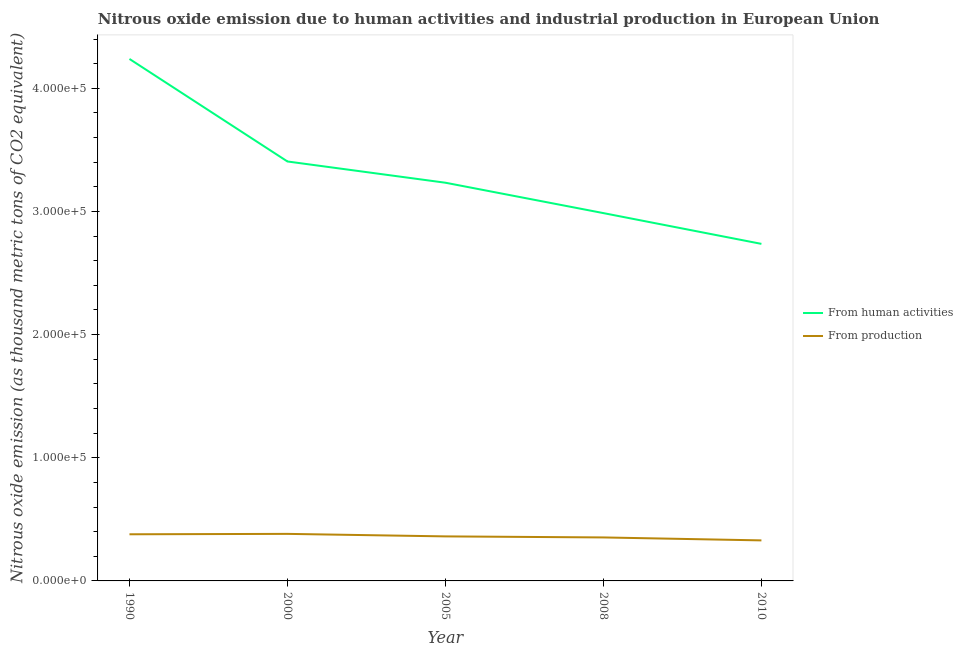Does the line corresponding to amount of emissions generated from industries intersect with the line corresponding to amount of emissions from human activities?
Offer a terse response. No. What is the amount of emissions generated from industries in 2000?
Offer a terse response. 3.82e+04. Across all years, what is the maximum amount of emissions generated from industries?
Your answer should be very brief. 3.82e+04. Across all years, what is the minimum amount of emissions generated from industries?
Offer a very short reply. 3.29e+04. In which year was the amount of emissions from human activities maximum?
Give a very brief answer. 1990. What is the total amount of emissions generated from industries in the graph?
Your response must be concise. 1.80e+05. What is the difference between the amount of emissions generated from industries in 1990 and that in 2000?
Your response must be concise. -328.9. What is the difference between the amount of emissions from human activities in 2008 and the amount of emissions generated from industries in 2000?
Make the answer very short. 2.60e+05. What is the average amount of emissions from human activities per year?
Give a very brief answer. 3.32e+05. In the year 2008, what is the difference between the amount of emissions generated from industries and amount of emissions from human activities?
Keep it short and to the point. -2.63e+05. What is the ratio of the amount of emissions from human activities in 2005 to that in 2008?
Offer a terse response. 1.08. Is the amount of emissions from human activities in 1990 less than that in 2000?
Your response must be concise. No. What is the difference between the highest and the second highest amount of emissions generated from industries?
Keep it short and to the point. 328.9. What is the difference between the highest and the lowest amount of emissions generated from industries?
Your answer should be very brief. 5298.1. Is the sum of the amount of emissions from human activities in 1990 and 2010 greater than the maximum amount of emissions generated from industries across all years?
Your response must be concise. Yes. Does the amount of emissions generated from industries monotonically increase over the years?
Your answer should be very brief. No. Is the amount of emissions generated from industries strictly less than the amount of emissions from human activities over the years?
Offer a very short reply. Yes. How many lines are there?
Keep it short and to the point. 2. Are the values on the major ticks of Y-axis written in scientific E-notation?
Make the answer very short. Yes. Does the graph contain any zero values?
Ensure brevity in your answer.  No. Does the graph contain grids?
Offer a very short reply. No. How many legend labels are there?
Your answer should be compact. 2. What is the title of the graph?
Provide a short and direct response. Nitrous oxide emission due to human activities and industrial production in European Union. What is the label or title of the X-axis?
Ensure brevity in your answer.  Year. What is the label or title of the Y-axis?
Ensure brevity in your answer.  Nitrous oxide emission (as thousand metric tons of CO2 equivalent). What is the Nitrous oxide emission (as thousand metric tons of CO2 equivalent) in From human activities in 1990?
Your response must be concise. 4.24e+05. What is the Nitrous oxide emission (as thousand metric tons of CO2 equivalent) in From production in 1990?
Offer a terse response. 3.79e+04. What is the Nitrous oxide emission (as thousand metric tons of CO2 equivalent) of From human activities in 2000?
Keep it short and to the point. 3.41e+05. What is the Nitrous oxide emission (as thousand metric tons of CO2 equivalent) of From production in 2000?
Keep it short and to the point. 3.82e+04. What is the Nitrous oxide emission (as thousand metric tons of CO2 equivalent) of From human activities in 2005?
Your response must be concise. 3.23e+05. What is the Nitrous oxide emission (as thousand metric tons of CO2 equivalent) in From production in 2005?
Your answer should be very brief. 3.62e+04. What is the Nitrous oxide emission (as thousand metric tons of CO2 equivalent) of From human activities in 2008?
Give a very brief answer. 2.99e+05. What is the Nitrous oxide emission (as thousand metric tons of CO2 equivalent) of From production in 2008?
Provide a short and direct response. 3.53e+04. What is the Nitrous oxide emission (as thousand metric tons of CO2 equivalent) of From human activities in 2010?
Ensure brevity in your answer.  2.74e+05. What is the Nitrous oxide emission (as thousand metric tons of CO2 equivalent) of From production in 2010?
Provide a succinct answer. 3.29e+04. Across all years, what is the maximum Nitrous oxide emission (as thousand metric tons of CO2 equivalent) of From human activities?
Your answer should be very brief. 4.24e+05. Across all years, what is the maximum Nitrous oxide emission (as thousand metric tons of CO2 equivalent) of From production?
Give a very brief answer. 3.82e+04. Across all years, what is the minimum Nitrous oxide emission (as thousand metric tons of CO2 equivalent) in From human activities?
Your answer should be compact. 2.74e+05. Across all years, what is the minimum Nitrous oxide emission (as thousand metric tons of CO2 equivalent) in From production?
Your answer should be compact. 3.29e+04. What is the total Nitrous oxide emission (as thousand metric tons of CO2 equivalent) in From human activities in the graph?
Your answer should be compact. 1.66e+06. What is the total Nitrous oxide emission (as thousand metric tons of CO2 equivalent) in From production in the graph?
Ensure brevity in your answer.  1.80e+05. What is the difference between the Nitrous oxide emission (as thousand metric tons of CO2 equivalent) in From human activities in 1990 and that in 2000?
Offer a very short reply. 8.33e+04. What is the difference between the Nitrous oxide emission (as thousand metric tons of CO2 equivalent) of From production in 1990 and that in 2000?
Give a very brief answer. -328.9. What is the difference between the Nitrous oxide emission (as thousand metric tons of CO2 equivalent) of From human activities in 1990 and that in 2005?
Keep it short and to the point. 1.01e+05. What is the difference between the Nitrous oxide emission (as thousand metric tons of CO2 equivalent) in From production in 1990 and that in 2005?
Offer a very short reply. 1721.7. What is the difference between the Nitrous oxide emission (as thousand metric tons of CO2 equivalent) in From human activities in 1990 and that in 2008?
Provide a succinct answer. 1.25e+05. What is the difference between the Nitrous oxide emission (as thousand metric tons of CO2 equivalent) of From production in 1990 and that in 2008?
Offer a very short reply. 2566.7. What is the difference between the Nitrous oxide emission (as thousand metric tons of CO2 equivalent) of From human activities in 1990 and that in 2010?
Provide a short and direct response. 1.50e+05. What is the difference between the Nitrous oxide emission (as thousand metric tons of CO2 equivalent) of From production in 1990 and that in 2010?
Provide a short and direct response. 4969.2. What is the difference between the Nitrous oxide emission (as thousand metric tons of CO2 equivalent) in From human activities in 2000 and that in 2005?
Provide a succinct answer. 1.72e+04. What is the difference between the Nitrous oxide emission (as thousand metric tons of CO2 equivalent) in From production in 2000 and that in 2005?
Offer a terse response. 2050.6. What is the difference between the Nitrous oxide emission (as thousand metric tons of CO2 equivalent) in From human activities in 2000 and that in 2008?
Give a very brief answer. 4.19e+04. What is the difference between the Nitrous oxide emission (as thousand metric tons of CO2 equivalent) in From production in 2000 and that in 2008?
Ensure brevity in your answer.  2895.6. What is the difference between the Nitrous oxide emission (as thousand metric tons of CO2 equivalent) in From human activities in 2000 and that in 2010?
Keep it short and to the point. 6.69e+04. What is the difference between the Nitrous oxide emission (as thousand metric tons of CO2 equivalent) of From production in 2000 and that in 2010?
Your answer should be very brief. 5298.1. What is the difference between the Nitrous oxide emission (as thousand metric tons of CO2 equivalent) of From human activities in 2005 and that in 2008?
Your answer should be very brief. 2.47e+04. What is the difference between the Nitrous oxide emission (as thousand metric tons of CO2 equivalent) of From production in 2005 and that in 2008?
Provide a short and direct response. 845. What is the difference between the Nitrous oxide emission (as thousand metric tons of CO2 equivalent) of From human activities in 2005 and that in 2010?
Your answer should be very brief. 4.97e+04. What is the difference between the Nitrous oxide emission (as thousand metric tons of CO2 equivalent) of From production in 2005 and that in 2010?
Keep it short and to the point. 3247.5. What is the difference between the Nitrous oxide emission (as thousand metric tons of CO2 equivalent) in From human activities in 2008 and that in 2010?
Your answer should be compact. 2.50e+04. What is the difference between the Nitrous oxide emission (as thousand metric tons of CO2 equivalent) in From production in 2008 and that in 2010?
Your answer should be very brief. 2402.5. What is the difference between the Nitrous oxide emission (as thousand metric tons of CO2 equivalent) of From human activities in 1990 and the Nitrous oxide emission (as thousand metric tons of CO2 equivalent) of From production in 2000?
Your answer should be very brief. 3.86e+05. What is the difference between the Nitrous oxide emission (as thousand metric tons of CO2 equivalent) of From human activities in 1990 and the Nitrous oxide emission (as thousand metric tons of CO2 equivalent) of From production in 2005?
Give a very brief answer. 3.88e+05. What is the difference between the Nitrous oxide emission (as thousand metric tons of CO2 equivalent) in From human activities in 1990 and the Nitrous oxide emission (as thousand metric tons of CO2 equivalent) in From production in 2008?
Your response must be concise. 3.89e+05. What is the difference between the Nitrous oxide emission (as thousand metric tons of CO2 equivalent) in From human activities in 1990 and the Nitrous oxide emission (as thousand metric tons of CO2 equivalent) in From production in 2010?
Your answer should be compact. 3.91e+05. What is the difference between the Nitrous oxide emission (as thousand metric tons of CO2 equivalent) in From human activities in 2000 and the Nitrous oxide emission (as thousand metric tons of CO2 equivalent) in From production in 2005?
Offer a very short reply. 3.04e+05. What is the difference between the Nitrous oxide emission (as thousand metric tons of CO2 equivalent) in From human activities in 2000 and the Nitrous oxide emission (as thousand metric tons of CO2 equivalent) in From production in 2008?
Offer a terse response. 3.05e+05. What is the difference between the Nitrous oxide emission (as thousand metric tons of CO2 equivalent) in From human activities in 2000 and the Nitrous oxide emission (as thousand metric tons of CO2 equivalent) in From production in 2010?
Offer a very short reply. 3.08e+05. What is the difference between the Nitrous oxide emission (as thousand metric tons of CO2 equivalent) of From human activities in 2005 and the Nitrous oxide emission (as thousand metric tons of CO2 equivalent) of From production in 2008?
Your response must be concise. 2.88e+05. What is the difference between the Nitrous oxide emission (as thousand metric tons of CO2 equivalent) in From human activities in 2005 and the Nitrous oxide emission (as thousand metric tons of CO2 equivalent) in From production in 2010?
Provide a succinct answer. 2.90e+05. What is the difference between the Nitrous oxide emission (as thousand metric tons of CO2 equivalent) in From human activities in 2008 and the Nitrous oxide emission (as thousand metric tons of CO2 equivalent) in From production in 2010?
Your response must be concise. 2.66e+05. What is the average Nitrous oxide emission (as thousand metric tons of CO2 equivalent) in From human activities per year?
Ensure brevity in your answer.  3.32e+05. What is the average Nitrous oxide emission (as thousand metric tons of CO2 equivalent) of From production per year?
Make the answer very short. 3.61e+04. In the year 1990, what is the difference between the Nitrous oxide emission (as thousand metric tons of CO2 equivalent) in From human activities and Nitrous oxide emission (as thousand metric tons of CO2 equivalent) in From production?
Your answer should be very brief. 3.86e+05. In the year 2000, what is the difference between the Nitrous oxide emission (as thousand metric tons of CO2 equivalent) of From human activities and Nitrous oxide emission (as thousand metric tons of CO2 equivalent) of From production?
Your response must be concise. 3.02e+05. In the year 2005, what is the difference between the Nitrous oxide emission (as thousand metric tons of CO2 equivalent) in From human activities and Nitrous oxide emission (as thousand metric tons of CO2 equivalent) in From production?
Make the answer very short. 2.87e+05. In the year 2008, what is the difference between the Nitrous oxide emission (as thousand metric tons of CO2 equivalent) of From human activities and Nitrous oxide emission (as thousand metric tons of CO2 equivalent) of From production?
Give a very brief answer. 2.63e+05. In the year 2010, what is the difference between the Nitrous oxide emission (as thousand metric tons of CO2 equivalent) in From human activities and Nitrous oxide emission (as thousand metric tons of CO2 equivalent) in From production?
Your response must be concise. 2.41e+05. What is the ratio of the Nitrous oxide emission (as thousand metric tons of CO2 equivalent) in From human activities in 1990 to that in 2000?
Offer a terse response. 1.24. What is the ratio of the Nitrous oxide emission (as thousand metric tons of CO2 equivalent) in From human activities in 1990 to that in 2005?
Your answer should be compact. 1.31. What is the ratio of the Nitrous oxide emission (as thousand metric tons of CO2 equivalent) of From production in 1990 to that in 2005?
Your answer should be very brief. 1.05. What is the ratio of the Nitrous oxide emission (as thousand metric tons of CO2 equivalent) in From human activities in 1990 to that in 2008?
Give a very brief answer. 1.42. What is the ratio of the Nitrous oxide emission (as thousand metric tons of CO2 equivalent) of From production in 1990 to that in 2008?
Give a very brief answer. 1.07. What is the ratio of the Nitrous oxide emission (as thousand metric tons of CO2 equivalent) in From human activities in 1990 to that in 2010?
Give a very brief answer. 1.55. What is the ratio of the Nitrous oxide emission (as thousand metric tons of CO2 equivalent) of From production in 1990 to that in 2010?
Offer a very short reply. 1.15. What is the ratio of the Nitrous oxide emission (as thousand metric tons of CO2 equivalent) in From human activities in 2000 to that in 2005?
Provide a short and direct response. 1.05. What is the ratio of the Nitrous oxide emission (as thousand metric tons of CO2 equivalent) of From production in 2000 to that in 2005?
Offer a terse response. 1.06. What is the ratio of the Nitrous oxide emission (as thousand metric tons of CO2 equivalent) of From human activities in 2000 to that in 2008?
Your response must be concise. 1.14. What is the ratio of the Nitrous oxide emission (as thousand metric tons of CO2 equivalent) of From production in 2000 to that in 2008?
Offer a very short reply. 1.08. What is the ratio of the Nitrous oxide emission (as thousand metric tons of CO2 equivalent) of From human activities in 2000 to that in 2010?
Keep it short and to the point. 1.24. What is the ratio of the Nitrous oxide emission (as thousand metric tons of CO2 equivalent) in From production in 2000 to that in 2010?
Provide a short and direct response. 1.16. What is the ratio of the Nitrous oxide emission (as thousand metric tons of CO2 equivalent) in From human activities in 2005 to that in 2008?
Keep it short and to the point. 1.08. What is the ratio of the Nitrous oxide emission (as thousand metric tons of CO2 equivalent) of From production in 2005 to that in 2008?
Offer a terse response. 1.02. What is the ratio of the Nitrous oxide emission (as thousand metric tons of CO2 equivalent) in From human activities in 2005 to that in 2010?
Your response must be concise. 1.18. What is the ratio of the Nitrous oxide emission (as thousand metric tons of CO2 equivalent) of From production in 2005 to that in 2010?
Your answer should be very brief. 1.1. What is the ratio of the Nitrous oxide emission (as thousand metric tons of CO2 equivalent) of From human activities in 2008 to that in 2010?
Offer a very short reply. 1.09. What is the ratio of the Nitrous oxide emission (as thousand metric tons of CO2 equivalent) of From production in 2008 to that in 2010?
Make the answer very short. 1.07. What is the difference between the highest and the second highest Nitrous oxide emission (as thousand metric tons of CO2 equivalent) of From human activities?
Provide a succinct answer. 8.33e+04. What is the difference between the highest and the second highest Nitrous oxide emission (as thousand metric tons of CO2 equivalent) in From production?
Your answer should be very brief. 328.9. What is the difference between the highest and the lowest Nitrous oxide emission (as thousand metric tons of CO2 equivalent) in From human activities?
Your answer should be very brief. 1.50e+05. What is the difference between the highest and the lowest Nitrous oxide emission (as thousand metric tons of CO2 equivalent) of From production?
Offer a terse response. 5298.1. 